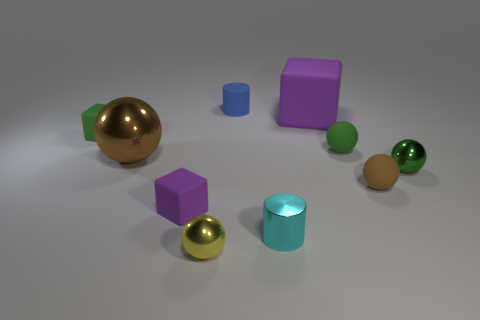Subtract all small rubber cubes. How many cubes are left? 1 Subtract all gray balls. How many purple cubes are left? 2 Subtract all green blocks. How many blocks are left? 2 Subtract 3 spheres. How many spheres are left? 2 Add 7 small cyan rubber spheres. How many small cyan rubber spheres exist? 7 Subtract 1 green cubes. How many objects are left? 9 Subtract all cubes. How many objects are left? 7 Subtract all blue blocks. Subtract all gray cylinders. How many blocks are left? 3 Subtract all tiny green rubber objects. Subtract all small purple matte spheres. How many objects are left? 8 Add 1 brown shiny balls. How many brown shiny balls are left? 2 